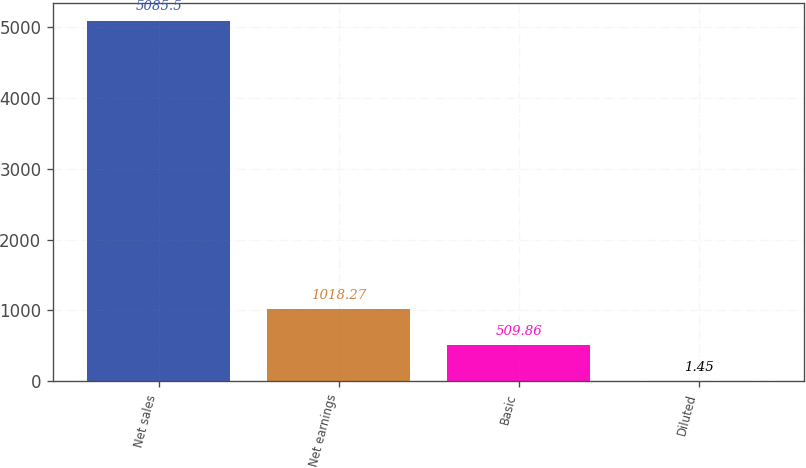<chart> <loc_0><loc_0><loc_500><loc_500><bar_chart><fcel>Net sales<fcel>Net earnings<fcel>Basic<fcel>Diluted<nl><fcel>5085.5<fcel>1018.27<fcel>509.86<fcel>1.45<nl></chart> 